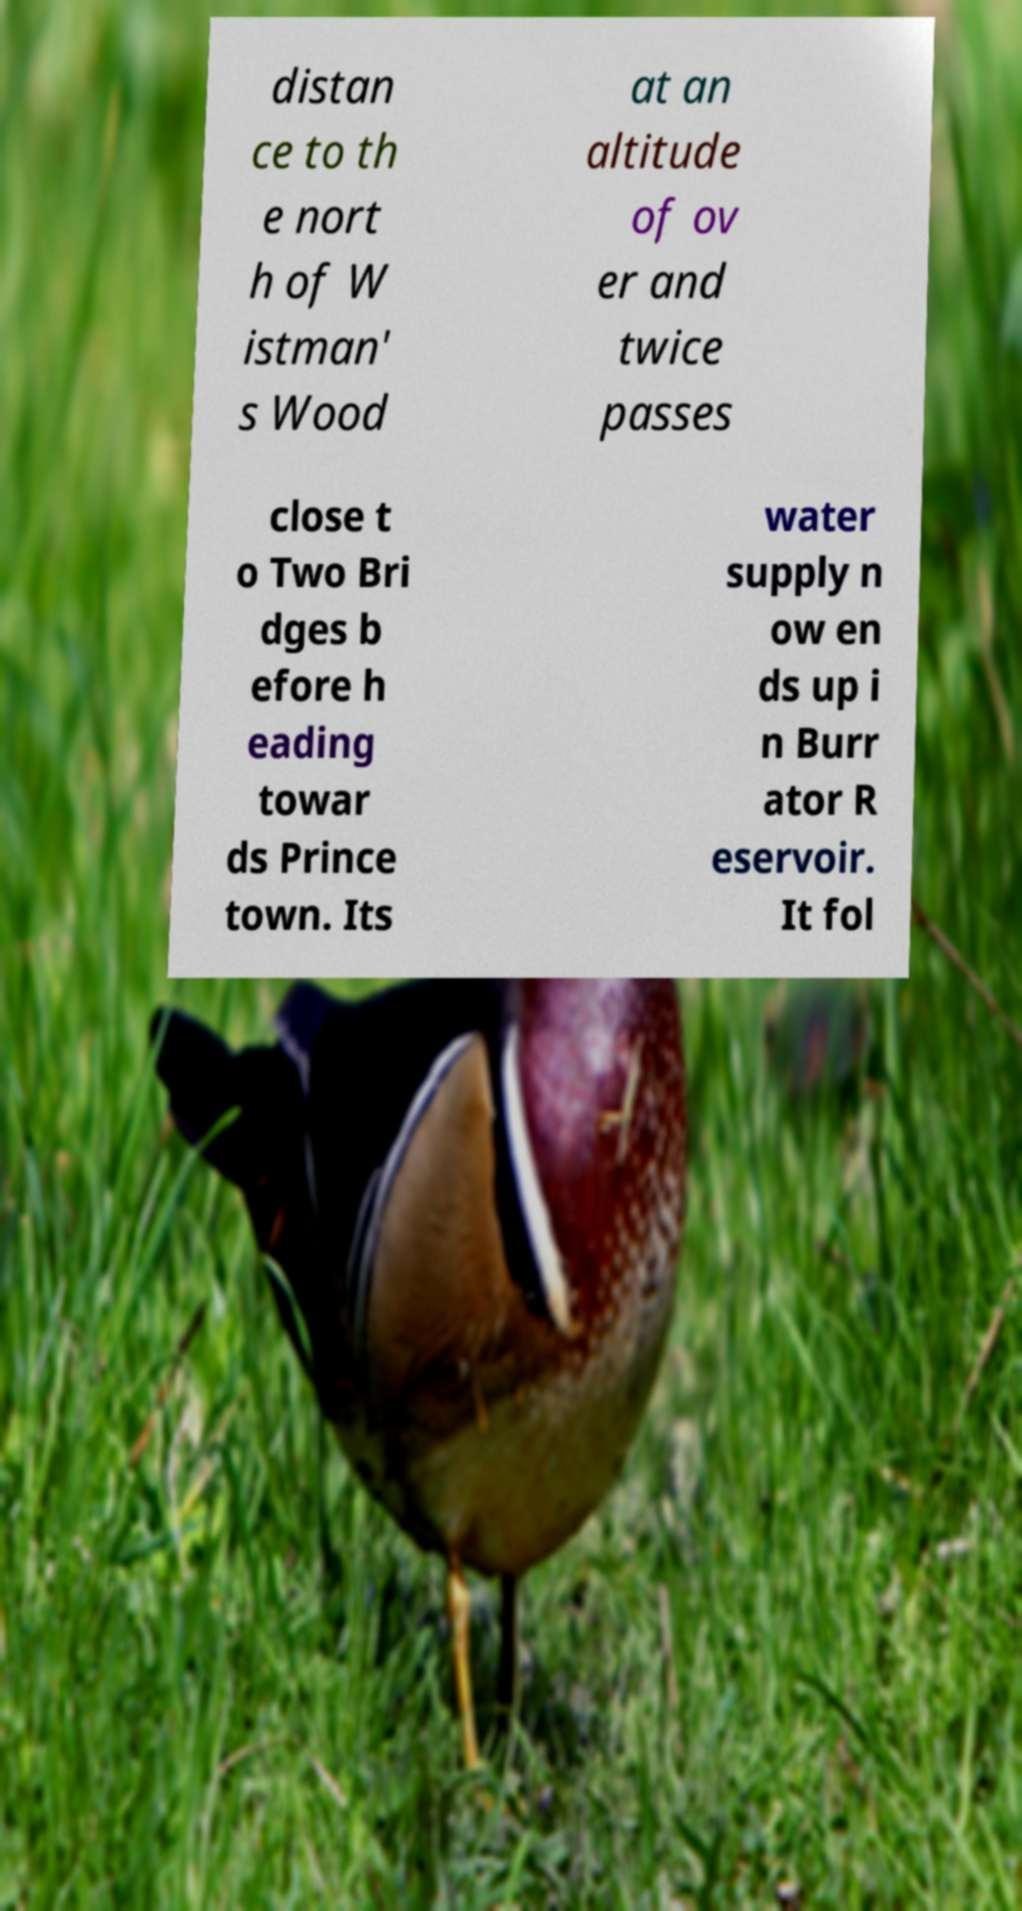Can you read and provide the text displayed in the image?This photo seems to have some interesting text. Can you extract and type it out for me? distan ce to th e nort h of W istman' s Wood at an altitude of ov er and twice passes close t o Two Bri dges b efore h eading towar ds Prince town. Its water supply n ow en ds up i n Burr ator R eservoir. It fol 